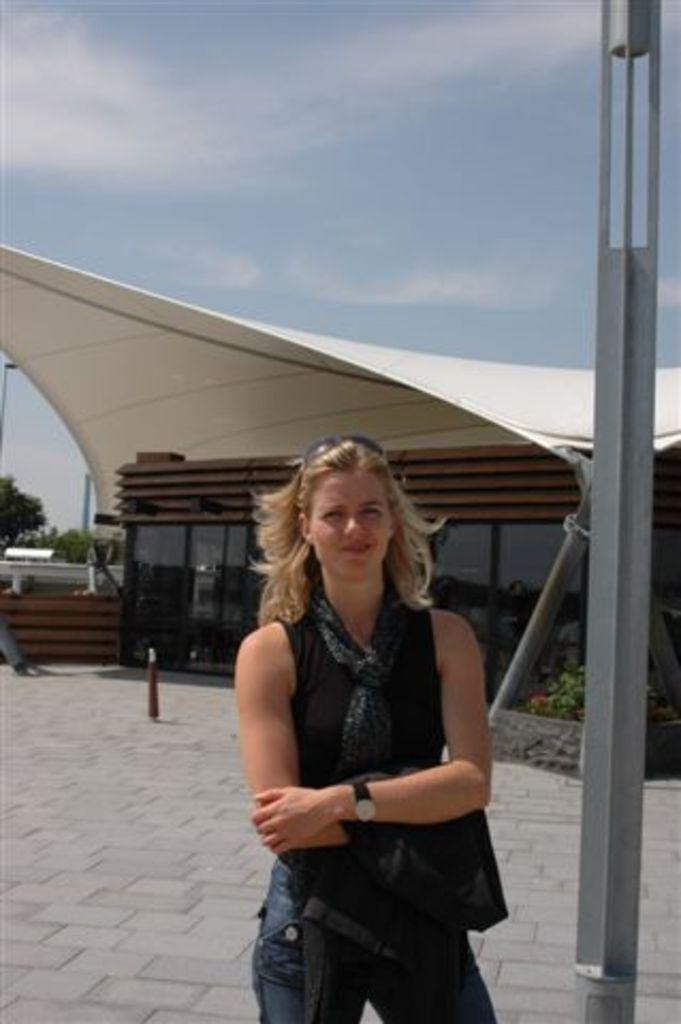What is the main subject in the foreground of the picture? There is a woman standing in the foreground of the picture. What can be seen on the right side of the picture? There is a pole on the right side of the picture. What type of vegetation is visible in the background of the picture? There are trees and a plant in the background of the picture. What type of structure is visible in the background of the picture? There is a building in the background of the picture. How would you describe the weather in the image? The sky is sunny in the image. How many kittens are playing with a quill in the yard in the image? There are no kittens or quills present in the image, and there is no yard visible. 